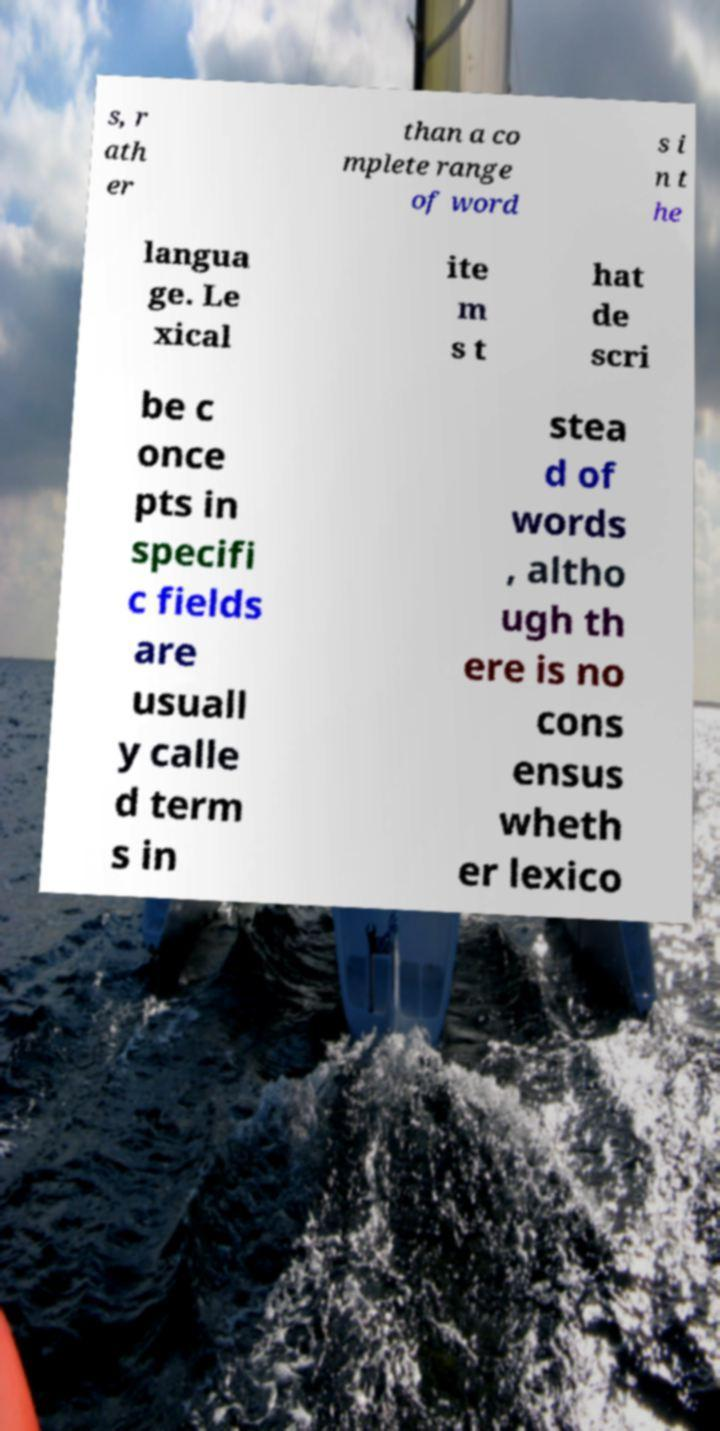For documentation purposes, I need the text within this image transcribed. Could you provide that? s, r ath er than a co mplete range of word s i n t he langua ge. Le xical ite m s t hat de scri be c once pts in specifi c fields are usuall y calle d term s in stea d of words , altho ugh th ere is no cons ensus wheth er lexico 